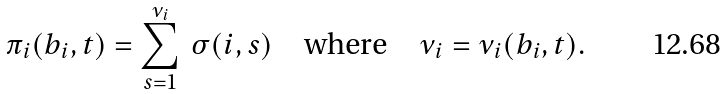<formula> <loc_0><loc_0><loc_500><loc_500>\pi _ { i } ( b _ { i } , t ) = \sum _ { s = 1 } ^ { \nu _ { i } } \, \sigma ( i , s ) \quad \text {where} \quad \nu _ { i } = \nu _ { i } ( b _ { i } , t ) .</formula> 